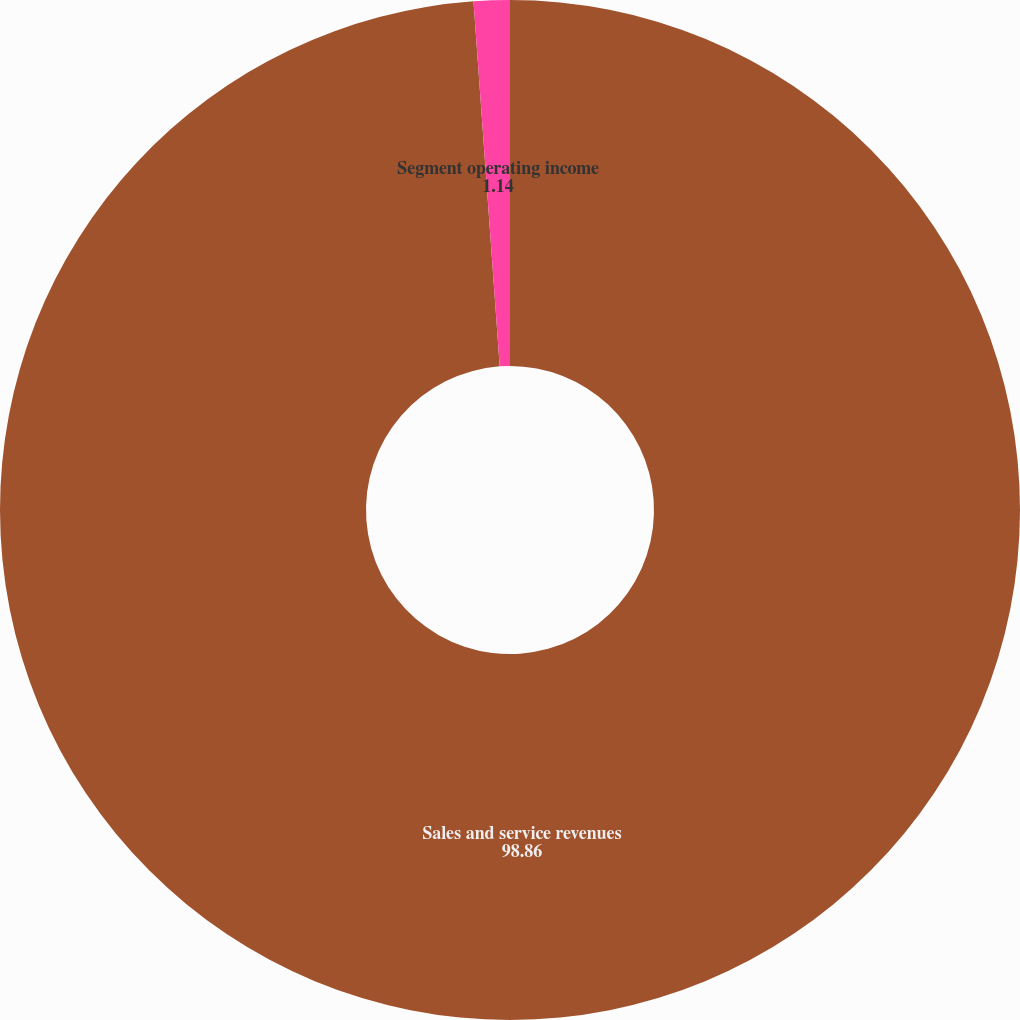Convert chart. <chart><loc_0><loc_0><loc_500><loc_500><pie_chart><fcel>Sales and service revenues<fcel>Segment operating income<nl><fcel>98.86%<fcel>1.14%<nl></chart> 